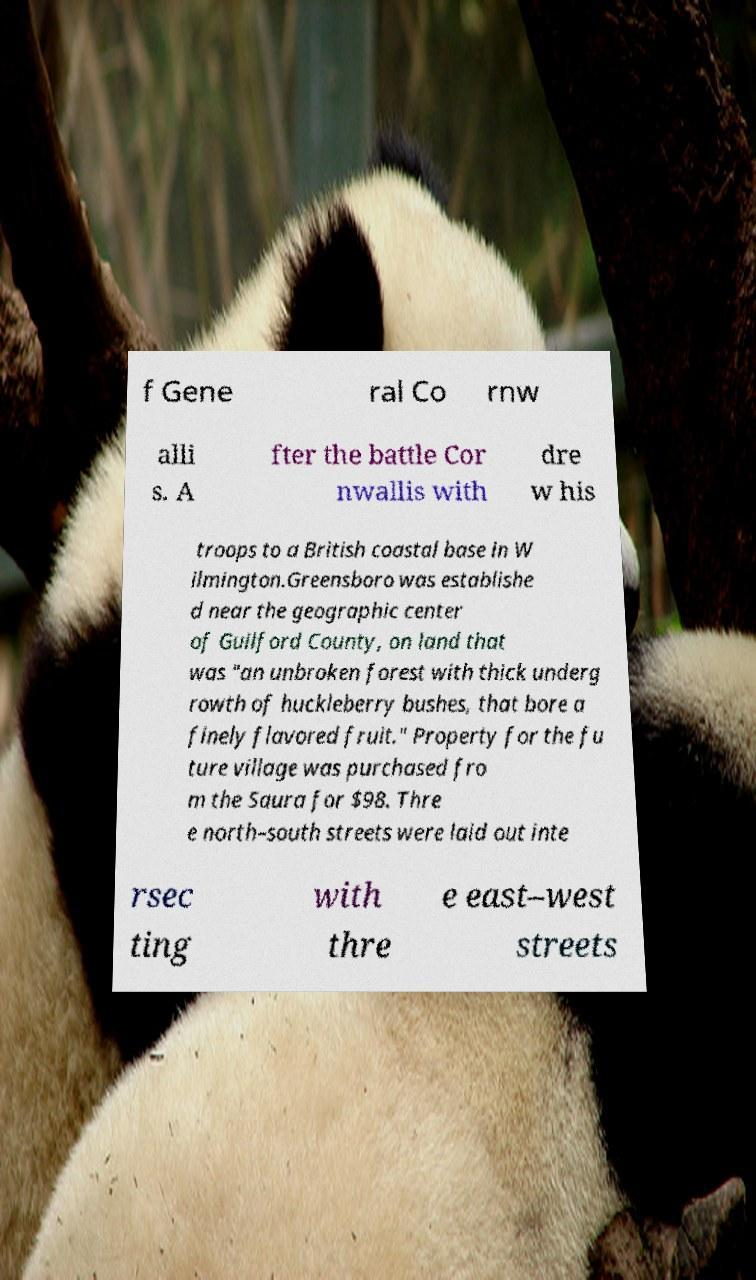Could you assist in decoding the text presented in this image and type it out clearly? f Gene ral Co rnw alli s. A fter the battle Cor nwallis with dre w his troops to a British coastal base in W ilmington.Greensboro was establishe d near the geographic center of Guilford County, on land that was "an unbroken forest with thick underg rowth of huckleberry bushes, that bore a finely flavored fruit." Property for the fu ture village was purchased fro m the Saura for $98. Thre e north–south streets were laid out inte rsec ting with thre e east–west streets 